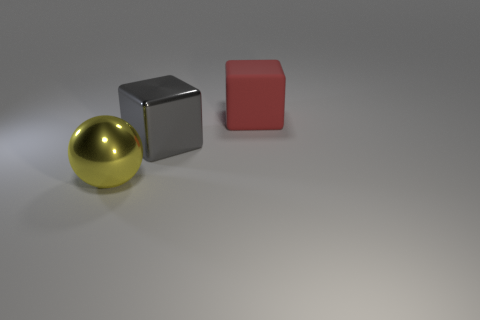Add 2 large metal balls. How many objects exist? 5 Subtract all balls. How many objects are left? 2 Subtract 0 yellow blocks. How many objects are left? 3 Subtract all red objects. Subtract all metal cubes. How many objects are left? 1 Add 3 spheres. How many spheres are left? 4 Add 3 rubber objects. How many rubber objects exist? 4 